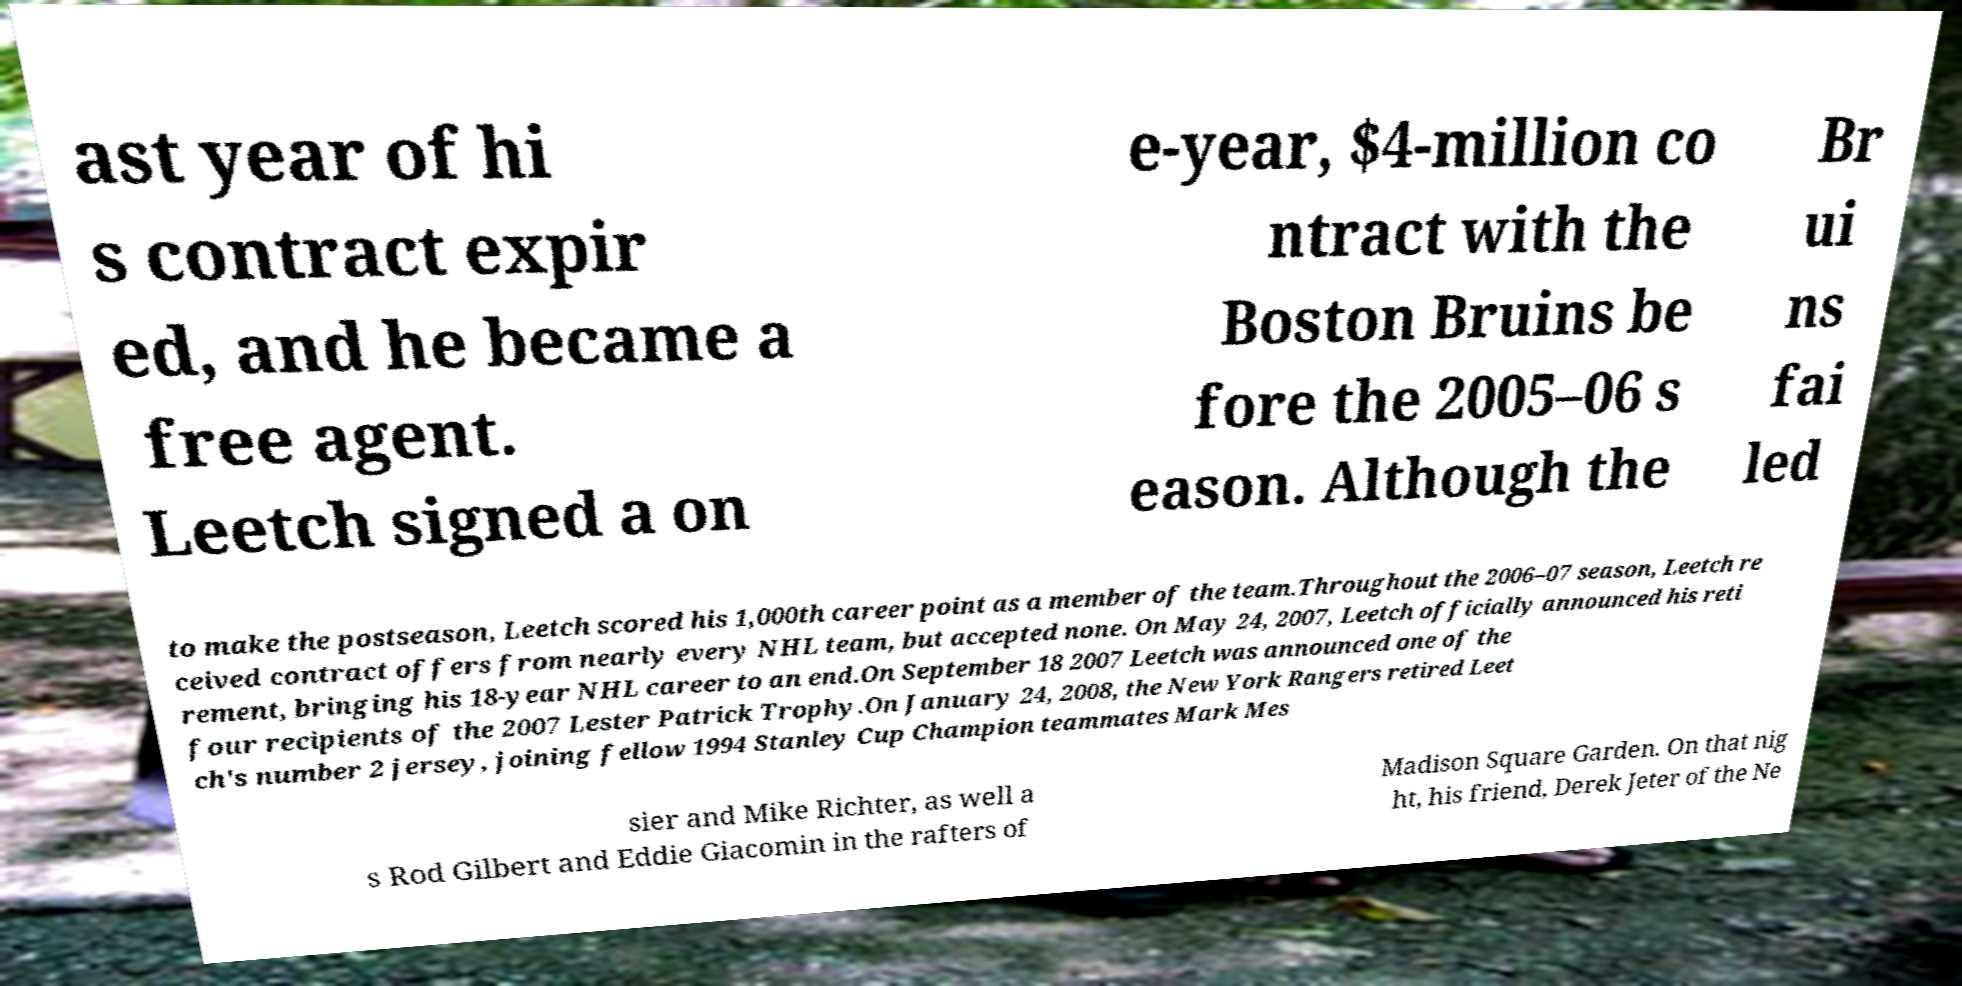Could you extract and type out the text from this image? ast year of hi s contract expir ed, and he became a free agent. Leetch signed a on e-year, $4-million co ntract with the Boston Bruins be fore the 2005–06 s eason. Although the Br ui ns fai led to make the postseason, Leetch scored his 1,000th career point as a member of the team.Throughout the 2006–07 season, Leetch re ceived contract offers from nearly every NHL team, but accepted none. On May 24, 2007, Leetch officially announced his reti rement, bringing his 18-year NHL career to an end.On September 18 2007 Leetch was announced one of the four recipients of the 2007 Lester Patrick Trophy.On January 24, 2008, the New York Rangers retired Leet ch's number 2 jersey, joining fellow 1994 Stanley Cup Champion teammates Mark Mes sier and Mike Richter, as well a s Rod Gilbert and Eddie Giacomin in the rafters of Madison Square Garden. On that nig ht, his friend, Derek Jeter of the Ne 